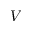<formula> <loc_0><loc_0><loc_500><loc_500>V</formula> 